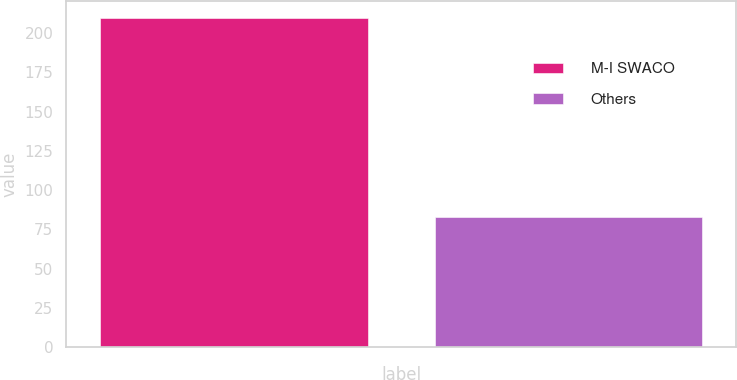<chart> <loc_0><loc_0><loc_500><loc_500><bar_chart><fcel>M-I SWACO<fcel>Others<nl><fcel>210<fcel>83<nl></chart> 